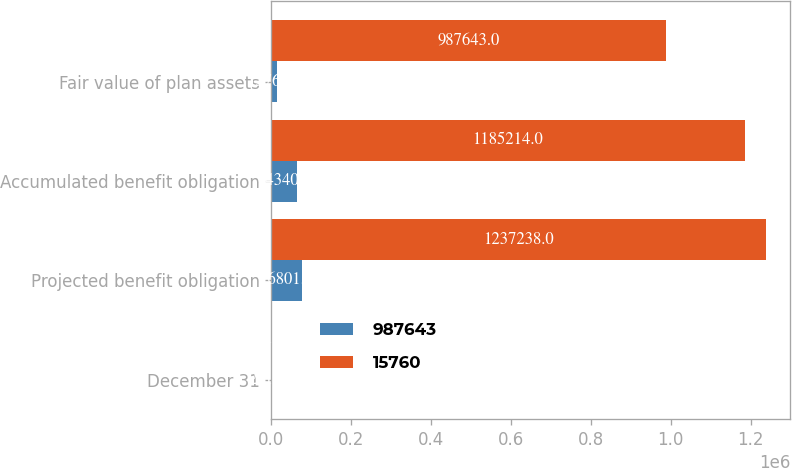<chart> <loc_0><loc_0><loc_500><loc_500><stacked_bar_chart><ecel><fcel>December 31<fcel>Projected benefit obligation<fcel>Accumulated benefit obligation<fcel>Fair value of plan assets<nl><fcel>987643<fcel>2013<fcel>76801<fcel>64340<fcel>15760<nl><fcel>15760<fcel>2012<fcel>1.23724e+06<fcel>1.18521e+06<fcel>987643<nl></chart> 